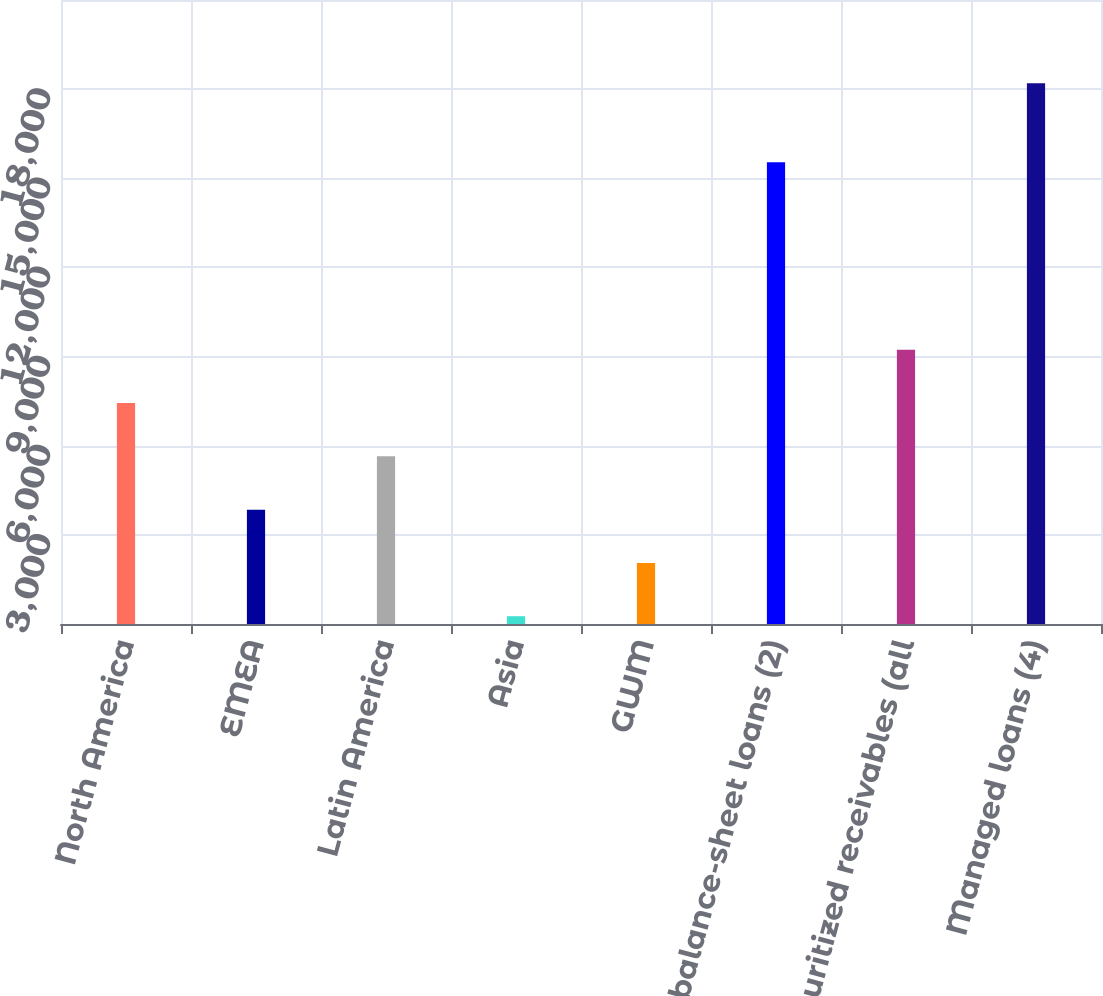<chart> <loc_0><loc_0><loc_500><loc_500><bar_chart><fcel>North America<fcel>EMEA<fcel>Latin America<fcel>Asia<fcel>GWM<fcel>On-balance-sheet loans (2)<fcel>Securitized receivables (all<fcel>Managed loans (4)<nl><fcel>7435.6<fcel>3848.8<fcel>5642.2<fcel>262<fcel>2055.4<fcel>15541<fcel>9229<fcel>18196<nl></chart> 